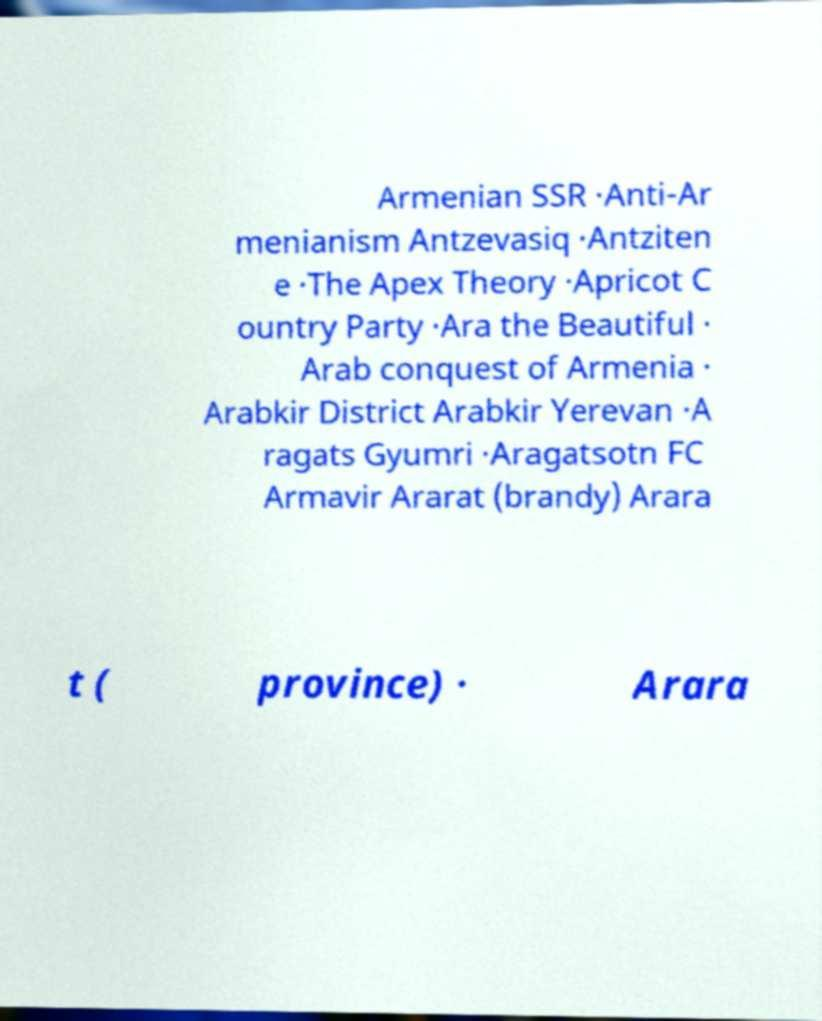For documentation purposes, I need the text within this image transcribed. Could you provide that? Armenian SSR ·Anti-Ar menianism Antzevasiq ·Antziten e ·The Apex Theory ·Apricot C ountry Party ·Ara the Beautiful · Arab conquest of Armenia · Arabkir District Arabkir Yerevan ·A ragats Gyumri ·Aragatsotn FC Armavir Ararat (brandy) Arara t ( province) · Arara 